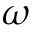Convert formula to latex. <formula><loc_0><loc_0><loc_500><loc_500>\omega</formula> 